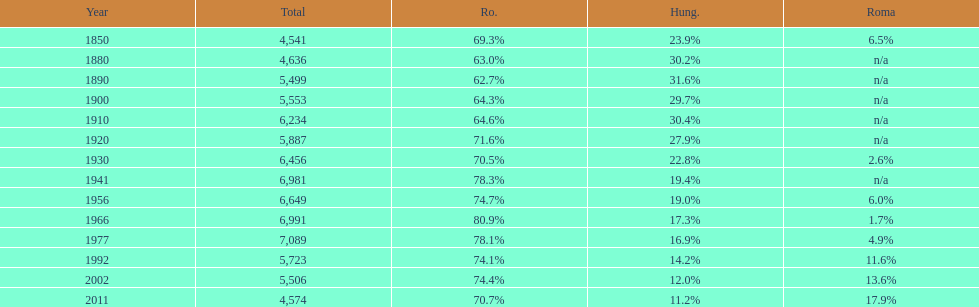Which year had the top percentage in romanian population? 1966. 